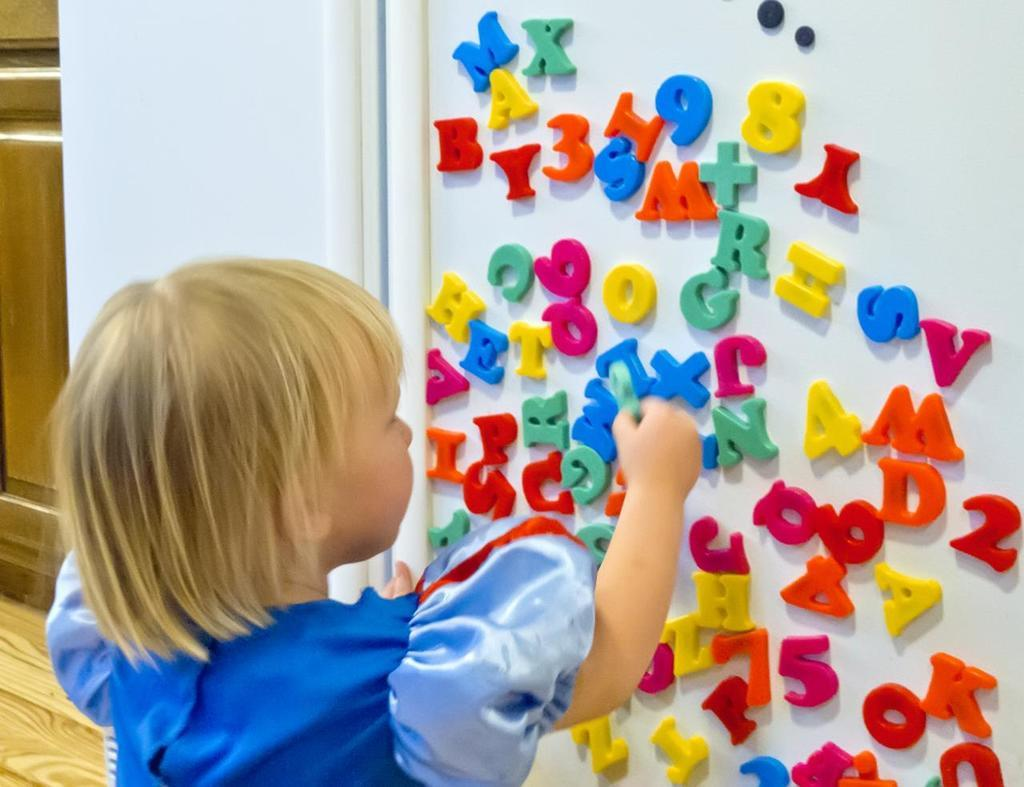Who is the main subject in the image? There is a girl in the image. What is the girl holding in the image? The girl is holding an object. What can be seen on the right side of the image? There is a wall on the right side of the image. What is written or depicted on the wall? There are letters on the wall. How many boots can be seen on the girl's feet in the image? There is no mention of boots in the image, and the girl's feet are not visible. What type of snakes are slithering around the girl in the image? There are no snakes present in the image. 